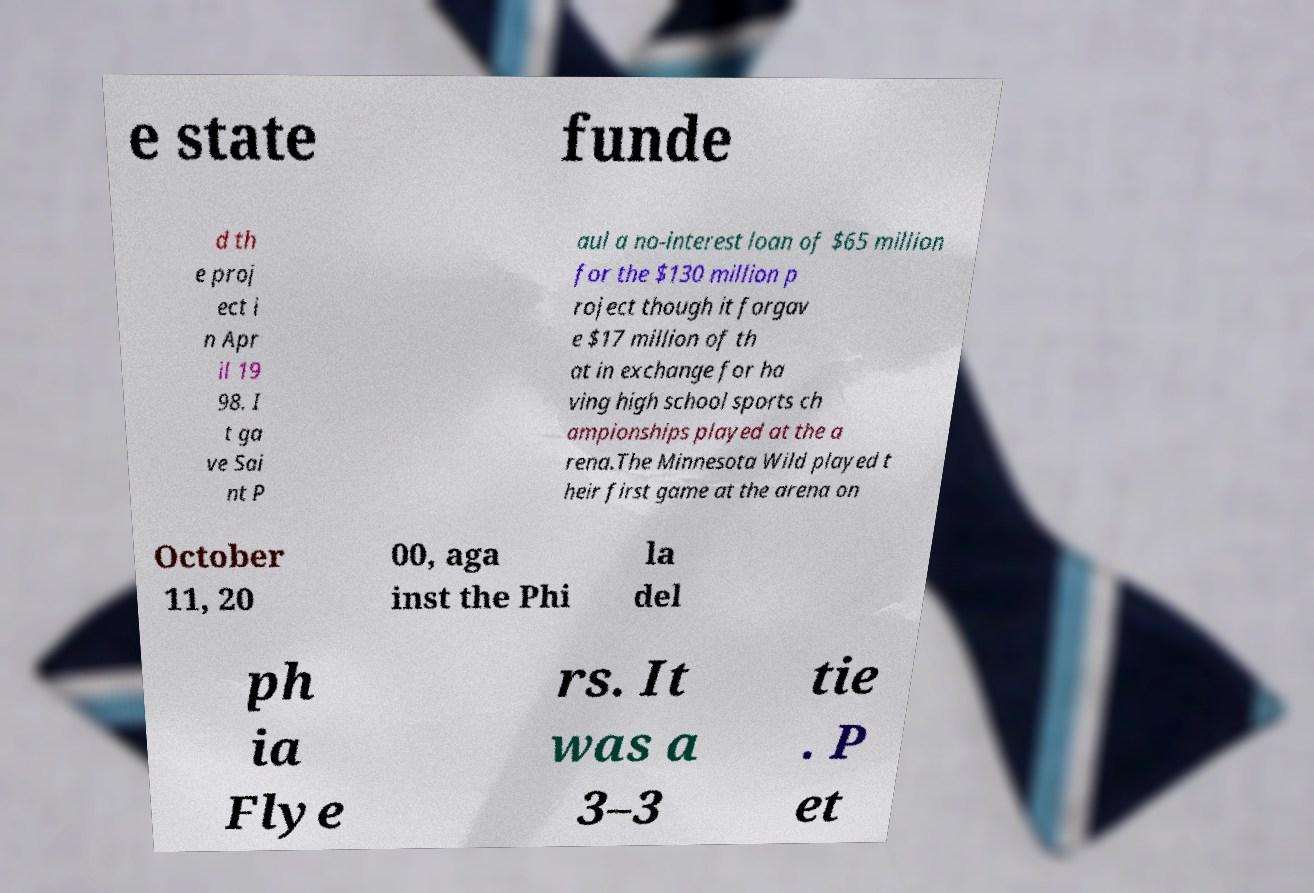There's text embedded in this image that I need extracted. Can you transcribe it verbatim? e state funde d th e proj ect i n Apr il 19 98. I t ga ve Sai nt P aul a no-interest loan of $65 million for the $130 million p roject though it forgav e $17 million of th at in exchange for ha ving high school sports ch ampionships played at the a rena.The Minnesota Wild played t heir first game at the arena on October 11, 20 00, aga inst the Phi la del ph ia Flye rs. It was a 3–3 tie . P et 